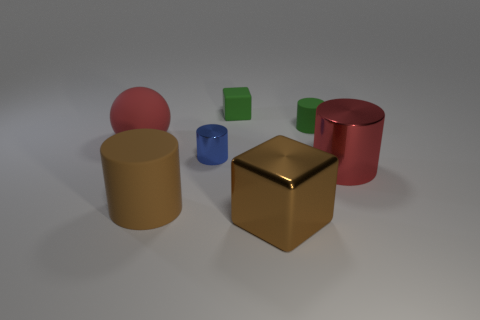Add 2 tiny green things. How many objects exist? 9 Subtract all red metal cylinders. How many cylinders are left? 3 Subtract all red cylinders. How many cylinders are left? 3 Subtract all balls. How many objects are left? 6 Subtract all purple spheres. Subtract all purple cylinders. How many spheres are left? 1 Subtract all cyan metallic cylinders. Subtract all brown shiny blocks. How many objects are left? 6 Add 1 small matte cylinders. How many small matte cylinders are left? 2 Add 1 gray balls. How many gray balls exist? 1 Subtract 1 brown blocks. How many objects are left? 6 